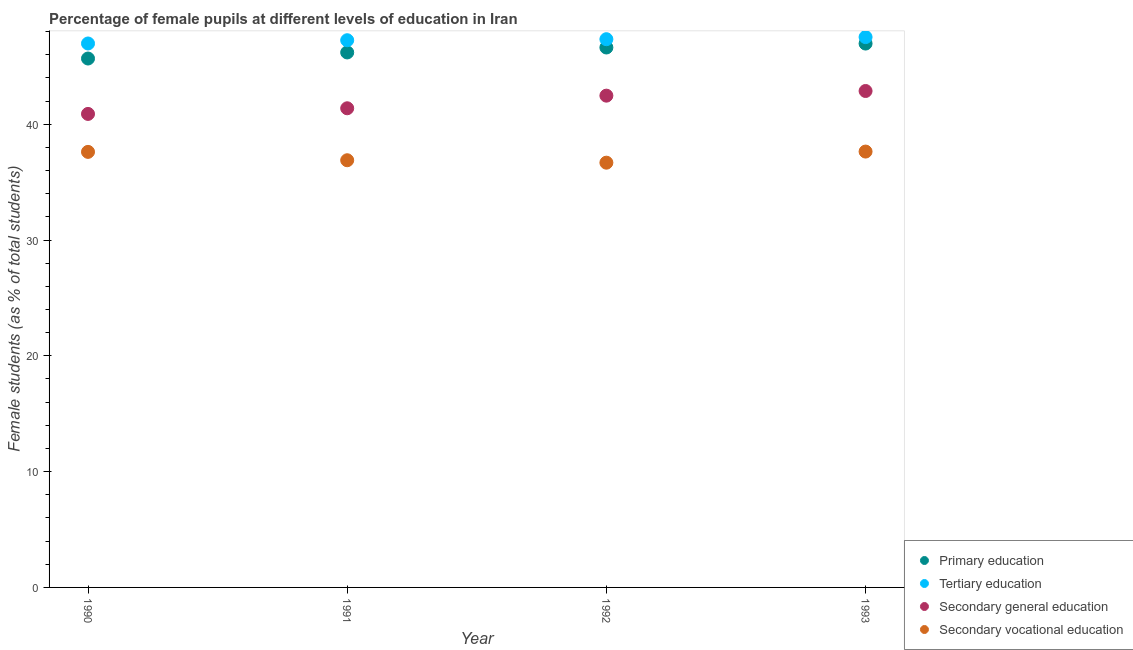How many different coloured dotlines are there?
Provide a succinct answer. 4. What is the percentage of female students in secondary education in 1993?
Offer a very short reply. 42.87. Across all years, what is the maximum percentage of female students in secondary education?
Offer a very short reply. 42.87. Across all years, what is the minimum percentage of female students in tertiary education?
Ensure brevity in your answer.  46.97. In which year was the percentage of female students in secondary education minimum?
Ensure brevity in your answer.  1990. What is the total percentage of female students in tertiary education in the graph?
Your response must be concise. 189.08. What is the difference between the percentage of female students in secondary vocational education in 1992 and that in 1993?
Your response must be concise. -0.96. What is the difference between the percentage of female students in tertiary education in 1990 and the percentage of female students in primary education in 1991?
Provide a short and direct response. 0.77. What is the average percentage of female students in secondary education per year?
Provide a short and direct response. 41.9. In the year 1990, what is the difference between the percentage of female students in tertiary education and percentage of female students in primary education?
Make the answer very short. 1.3. In how many years, is the percentage of female students in primary education greater than 38 %?
Ensure brevity in your answer.  4. What is the ratio of the percentage of female students in secondary education in 1990 to that in 1991?
Offer a terse response. 0.99. Is the difference between the percentage of female students in tertiary education in 1991 and 1992 greater than the difference between the percentage of female students in primary education in 1991 and 1992?
Your response must be concise. Yes. What is the difference between the highest and the second highest percentage of female students in secondary vocational education?
Your response must be concise. 0.03. What is the difference between the highest and the lowest percentage of female students in primary education?
Provide a succinct answer. 1.29. Is it the case that in every year, the sum of the percentage of female students in secondary vocational education and percentage of female students in primary education is greater than the sum of percentage of female students in tertiary education and percentage of female students in secondary education?
Keep it short and to the point. No. Is it the case that in every year, the sum of the percentage of female students in primary education and percentage of female students in tertiary education is greater than the percentage of female students in secondary education?
Your answer should be compact. Yes. Is the percentage of female students in tertiary education strictly greater than the percentage of female students in primary education over the years?
Your answer should be compact. Yes. How many years are there in the graph?
Offer a very short reply. 4. What is the difference between two consecutive major ticks on the Y-axis?
Offer a terse response. 10. What is the title of the graph?
Give a very brief answer. Percentage of female pupils at different levels of education in Iran. Does "UNTA" appear as one of the legend labels in the graph?
Your response must be concise. No. What is the label or title of the Y-axis?
Provide a short and direct response. Female students (as % of total students). What is the Female students (as % of total students) in Primary education in 1990?
Your answer should be very brief. 45.67. What is the Female students (as % of total students) of Tertiary education in 1990?
Ensure brevity in your answer.  46.97. What is the Female students (as % of total students) in Secondary general education in 1990?
Offer a very short reply. 40.89. What is the Female students (as % of total students) in Secondary vocational education in 1990?
Offer a very short reply. 37.61. What is the Female students (as % of total students) of Primary education in 1991?
Provide a short and direct response. 46.2. What is the Female students (as % of total students) of Tertiary education in 1991?
Your answer should be compact. 47.25. What is the Female students (as % of total students) of Secondary general education in 1991?
Your answer should be very brief. 41.37. What is the Female students (as % of total students) of Secondary vocational education in 1991?
Your response must be concise. 36.89. What is the Female students (as % of total students) in Primary education in 1992?
Offer a terse response. 46.62. What is the Female students (as % of total students) in Tertiary education in 1992?
Your response must be concise. 47.34. What is the Female students (as % of total students) in Secondary general education in 1992?
Ensure brevity in your answer.  42.46. What is the Female students (as % of total students) of Secondary vocational education in 1992?
Offer a terse response. 36.68. What is the Female students (as % of total students) of Primary education in 1993?
Provide a succinct answer. 46.96. What is the Female students (as % of total students) in Tertiary education in 1993?
Your answer should be compact. 47.52. What is the Female students (as % of total students) of Secondary general education in 1993?
Keep it short and to the point. 42.87. What is the Female students (as % of total students) in Secondary vocational education in 1993?
Offer a very short reply. 37.64. Across all years, what is the maximum Female students (as % of total students) in Primary education?
Give a very brief answer. 46.96. Across all years, what is the maximum Female students (as % of total students) in Tertiary education?
Ensure brevity in your answer.  47.52. Across all years, what is the maximum Female students (as % of total students) of Secondary general education?
Your response must be concise. 42.87. Across all years, what is the maximum Female students (as % of total students) of Secondary vocational education?
Ensure brevity in your answer.  37.64. Across all years, what is the minimum Female students (as % of total students) in Primary education?
Your answer should be compact. 45.67. Across all years, what is the minimum Female students (as % of total students) in Tertiary education?
Offer a very short reply. 46.97. Across all years, what is the minimum Female students (as % of total students) of Secondary general education?
Your response must be concise. 40.89. Across all years, what is the minimum Female students (as % of total students) of Secondary vocational education?
Provide a short and direct response. 36.68. What is the total Female students (as % of total students) in Primary education in the graph?
Your response must be concise. 185.45. What is the total Female students (as % of total students) of Tertiary education in the graph?
Your response must be concise. 189.08. What is the total Female students (as % of total students) in Secondary general education in the graph?
Your response must be concise. 167.59. What is the total Female students (as % of total students) in Secondary vocational education in the graph?
Ensure brevity in your answer.  148.81. What is the difference between the Female students (as % of total students) in Primary education in 1990 and that in 1991?
Your answer should be very brief. -0.52. What is the difference between the Female students (as % of total students) of Tertiary education in 1990 and that in 1991?
Provide a succinct answer. -0.28. What is the difference between the Female students (as % of total students) of Secondary general education in 1990 and that in 1991?
Your answer should be compact. -0.49. What is the difference between the Female students (as % of total students) in Secondary vocational education in 1990 and that in 1991?
Provide a succinct answer. 0.72. What is the difference between the Female students (as % of total students) of Primary education in 1990 and that in 1992?
Your answer should be compact. -0.95. What is the difference between the Female students (as % of total students) in Tertiary education in 1990 and that in 1992?
Offer a terse response. -0.37. What is the difference between the Female students (as % of total students) in Secondary general education in 1990 and that in 1992?
Offer a very short reply. -1.58. What is the difference between the Female students (as % of total students) of Secondary vocational education in 1990 and that in 1992?
Your response must be concise. 0.93. What is the difference between the Female students (as % of total students) in Primary education in 1990 and that in 1993?
Your response must be concise. -1.29. What is the difference between the Female students (as % of total students) in Tertiary education in 1990 and that in 1993?
Offer a very short reply. -0.55. What is the difference between the Female students (as % of total students) in Secondary general education in 1990 and that in 1993?
Your response must be concise. -1.98. What is the difference between the Female students (as % of total students) of Secondary vocational education in 1990 and that in 1993?
Ensure brevity in your answer.  -0.03. What is the difference between the Female students (as % of total students) of Primary education in 1991 and that in 1992?
Make the answer very short. -0.43. What is the difference between the Female students (as % of total students) in Tertiary education in 1991 and that in 1992?
Offer a terse response. -0.09. What is the difference between the Female students (as % of total students) in Secondary general education in 1991 and that in 1992?
Make the answer very short. -1.09. What is the difference between the Female students (as % of total students) of Secondary vocational education in 1991 and that in 1992?
Your answer should be compact. 0.21. What is the difference between the Female students (as % of total students) in Primary education in 1991 and that in 1993?
Offer a terse response. -0.77. What is the difference between the Female students (as % of total students) of Tertiary education in 1991 and that in 1993?
Ensure brevity in your answer.  -0.27. What is the difference between the Female students (as % of total students) in Secondary general education in 1991 and that in 1993?
Your answer should be compact. -1.49. What is the difference between the Female students (as % of total students) in Secondary vocational education in 1991 and that in 1993?
Provide a short and direct response. -0.75. What is the difference between the Female students (as % of total students) in Primary education in 1992 and that in 1993?
Ensure brevity in your answer.  -0.34. What is the difference between the Female students (as % of total students) of Tertiary education in 1992 and that in 1993?
Ensure brevity in your answer.  -0.18. What is the difference between the Female students (as % of total students) of Secondary general education in 1992 and that in 1993?
Offer a very short reply. -0.4. What is the difference between the Female students (as % of total students) in Secondary vocational education in 1992 and that in 1993?
Provide a short and direct response. -0.96. What is the difference between the Female students (as % of total students) of Primary education in 1990 and the Female students (as % of total students) of Tertiary education in 1991?
Your answer should be compact. -1.58. What is the difference between the Female students (as % of total students) of Primary education in 1990 and the Female students (as % of total students) of Secondary general education in 1991?
Ensure brevity in your answer.  4.3. What is the difference between the Female students (as % of total students) of Primary education in 1990 and the Female students (as % of total students) of Secondary vocational education in 1991?
Keep it short and to the point. 8.78. What is the difference between the Female students (as % of total students) of Tertiary education in 1990 and the Female students (as % of total students) of Secondary general education in 1991?
Your answer should be very brief. 5.59. What is the difference between the Female students (as % of total students) in Tertiary education in 1990 and the Female students (as % of total students) in Secondary vocational education in 1991?
Offer a terse response. 10.08. What is the difference between the Female students (as % of total students) in Secondary general education in 1990 and the Female students (as % of total students) in Secondary vocational education in 1991?
Provide a short and direct response. 4. What is the difference between the Female students (as % of total students) of Primary education in 1990 and the Female students (as % of total students) of Tertiary education in 1992?
Provide a short and direct response. -1.67. What is the difference between the Female students (as % of total students) in Primary education in 1990 and the Female students (as % of total students) in Secondary general education in 1992?
Your answer should be very brief. 3.21. What is the difference between the Female students (as % of total students) of Primary education in 1990 and the Female students (as % of total students) of Secondary vocational education in 1992?
Ensure brevity in your answer.  8.99. What is the difference between the Female students (as % of total students) of Tertiary education in 1990 and the Female students (as % of total students) of Secondary general education in 1992?
Make the answer very short. 4.5. What is the difference between the Female students (as % of total students) of Tertiary education in 1990 and the Female students (as % of total students) of Secondary vocational education in 1992?
Ensure brevity in your answer.  10.29. What is the difference between the Female students (as % of total students) of Secondary general education in 1990 and the Female students (as % of total students) of Secondary vocational education in 1992?
Provide a short and direct response. 4.21. What is the difference between the Female students (as % of total students) of Primary education in 1990 and the Female students (as % of total students) of Tertiary education in 1993?
Keep it short and to the point. -1.85. What is the difference between the Female students (as % of total students) in Primary education in 1990 and the Female students (as % of total students) in Secondary general education in 1993?
Provide a short and direct response. 2.8. What is the difference between the Female students (as % of total students) in Primary education in 1990 and the Female students (as % of total students) in Secondary vocational education in 1993?
Your response must be concise. 8.03. What is the difference between the Female students (as % of total students) in Tertiary education in 1990 and the Female students (as % of total students) in Secondary general education in 1993?
Keep it short and to the point. 4.1. What is the difference between the Female students (as % of total students) in Tertiary education in 1990 and the Female students (as % of total students) in Secondary vocational education in 1993?
Provide a short and direct response. 9.33. What is the difference between the Female students (as % of total students) in Secondary general education in 1990 and the Female students (as % of total students) in Secondary vocational education in 1993?
Provide a short and direct response. 3.25. What is the difference between the Female students (as % of total students) of Primary education in 1991 and the Female students (as % of total students) of Tertiary education in 1992?
Your answer should be compact. -1.14. What is the difference between the Female students (as % of total students) in Primary education in 1991 and the Female students (as % of total students) in Secondary general education in 1992?
Your answer should be compact. 3.73. What is the difference between the Female students (as % of total students) of Primary education in 1991 and the Female students (as % of total students) of Secondary vocational education in 1992?
Make the answer very short. 9.52. What is the difference between the Female students (as % of total students) of Tertiary education in 1991 and the Female students (as % of total students) of Secondary general education in 1992?
Provide a short and direct response. 4.79. What is the difference between the Female students (as % of total students) in Tertiary education in 1991 and the Female students (as % of total students) in Secondary vocational education in 1992?
Keep it short and to the point. 10.57. What is the difference between the Female students (as % of total students) of Secondary general education in 1991 and the Female students (as % of total students) of Secondary vocational education in 1992?
Keep it short and to the point. 4.7. What is the difference between the Female students (as % of total students) of Primary education in 1991 and the Female students (as % of total students) of Tertiary education in 1993?
Offer a very short reply. -1.33. What is the difference between the Female students (as % of total students) of Primary education in 1991 and the Female students (as % of total students) of Secondary general education in 1993?
Keep it short and to the point. 3.33. What is the difference between the Female students (as % of total students) in Primary education in 1991 and the Female students (as % of total students) in Secondary vocational education in 1993?
Make the answer very short. 8.56. What is the difference between the Female students (as % of total students) of Tertiary education in 1991 and the Female students (as % of total students) of Secondary general education in 1993?
Provide a succinct answer. 4.38. What is the difference between the Female students (as % of total students) of Tertiary education in 1991 and the Female students (as % of total students) of Secondary vocational education in 1993?
Your answer should be very brief. 9.61. What is the difference between the Female students (as % of total students) of Secondary general education in 1991 and the Female students (as % of total students) of Secondary vocational education in 1993?
Provide a succinct answer. 3.74. What is the difference between the Female students (as % of total students) in Primary education in 1992 and the Female students (as % of total students) in Tertiary education in 1993?
Offer a very short reply. -0.9. What is the difference between the Female students (as % of total students) in Primary education in 1992 and the Female students (as % of total students) in Secondary general education in 1993?
Your response must be concise. 3.76. What is the difference between the Female students (as % of total students) in Primary education in 1992 and the Female students (as % of total students) in Secondary vocational education in 1993?
Your answer should be compact. 8.99. What is the difference between the Female students (as % of total students) of Tertiary education in 1992 and the Female students (as % of total students) of Secondary general education in 1993?
Offer a terse response. 4.47. What is the difference between the Female students (as % of total students) of Tertiary education in 1992 and the Female students (as % of total students) of Secondary vocational education in 1993?
Your answer should be compact. 9.7. What is the difference between the Female students (as % of total students) in Secondary general education in 1992 and the Female students (as % of total students) in Secondary vocational education in 1993?
Provide a short and direct response. 4.83. What is the average Female students (as % of total students) in Primary education per year?
Your answer should be compact. 46.36. What is the average Female students (as % of total students) in Tertiary education per year?
Offer a very short reply. 47.27. What is the average Female students (as % of total students) in Secondary general education per year?
Your answer should be very brief. 41.9. What is the average Female students (as % of total students) of Secondary vocational education per year?
Your answer should be compact. 37.2. In the year 1990, what is the difference between the Female students (as % of total students) of Primary education and Female students (as % of total students) of Tertiary education?
Offer a terse response. -1.3. In the year 1990, what is the difference between the Female students (as % of total students) of Primary education and Female students (as % of total students) of Secondary general education?
Your answer should be compact. 4.78. In the year 1990, what is the difference between the Female students (as % of total students) of Primary education and Female students (as % of total students) of Secondary vocational education?
Offer a terse response. 8.06. In the year 1990, what is the difference between the Female students (as % of total students) in Tertiary education and Female students (as % of total students) in Secondary general education?
Offer a very short reply. 6.08. In the year 1990, what is the difference between the Female students (as % of total students) of Tertiary education and Female students (as % of total students) of Secondary vocational education?
Give a very brief answer. 9.36. In the year 1990, what is the difference between the Female students (as % of total students) in Secondary general education and Female students (as % of total students) in Secondary vocational education?
Make the answer very short. 3.28. In the year 1991, what is the difference between the Female students (as % of total students) in Primary education and Female students (as % of total students) in Tertiary education?
Give a very brief answer. -1.06. In the year 1991, what is the difference between the Female students (as % of total students) in Primary education and Female students (as % of total students) in Secondary general education?
Ensure brevity in your answer.  4.82. In the year 1991, what is the difference between the Female students (as % of total students) in Primary education and Female students (as % of total students) in Secondary vocational education?
Give a very brief answer. 9.31. In the year 1991, what is the difference between the Female students (as % of total students) in Tertiary education and Female students (as % of total students) in Secondary general education?
Ensure brevity in your answer.  5.88. In the year 1991, what is the difference between the Female students (as % of total students) in Tertiary education and Female students (as % of total students) in Secondary vocational education?
Keep it short and to the point. 10.36. In the year 1991, what is the difference between the Female students (as % of total students) in Secondary general education and Female students (as % of total students) in Secondary vocational education?
Offer a very short reply. 4.49. In the year 1992, what is the difference between the Female students (as % of total students) in Primary education and Female students (as % of total students) in Tertiary education?
Make the answer very short. -0.72. In the year 1992, what is the difference between the Female students (as % of total students) of Primary education and Female students (as % of total students) of Secondary general education?
Provide a succinct answer. 4.16. In the year 1992, what is the difference between the Female students (as % of total students) in Primary education and Female students (as % of total students) in Secondary vocational education?
Keep it short and to the point. 9.95. In the year 1992, what is the difference between the Female students (as % of total students) of Tertiary education and Female students (as % of total students) of Secondary general education?
Ensure brevity in your answer.  4.87. In the year 1992, what is the difference between the Female students (as % of total students) of Tertiary education and Female students (as % of total students) of Secondary vocational education?
Your answer should be compact. 10.66. In the year 1992, what is the difference between the Female students (as % of total students) in Secondary general education and Female students (as % of total students) in Secondary vocational education?
Make the answer very short. 5.79. In the year 1993, what is the difference between the Female students (as % of total students) of Primary education and Female students (as % of total students) of Tertiary education?
Keep it short and to the point. -0.56. In the year 1993, what is the difference between the Female students (as % of total students) in Primary education and Female students (as % of total students) in Secondary general education?
Provide a succinct answer. 4.1. In the year 1993, what is the difference between the Female students (as % of total students) in Primary education and Female students (as % of total students) in Secondary vocational education?
Your answer should be compact. 9.33. In the year 1993, what is the difference between the Female students (as % of total students) of Tertiary education and Female students (as % of total students) of Secondary general education?
Offer a terse response. 4.65. In the year 1993, what is the difference between the Female students (as % of total students) of Tertiary education and Female students (as % of total students) of Secondary vocational education?
Your answer should be compact. 9.88. In the year 1993, what is the difference between the Female students (as % of total students) in Secondary general education and Female students (as % of total students) in Secondary vocational education?
Your answer should be compact. 5.23. What is the ratio of the Female students (as % of total students) in Primary education in 1990 to that in 1991?
Give a very brief answer. 0.99. What is the ratio of the Female students (as % of total students) of Secondary vocational education in 1990 to that in 1991?
Your answer should be compact. 1.02. What is the ratio of the Female students (as % of total students) of Primary education in 1990 to that in 1992?
Offer a very short reply. 0.98. What is the ratio of the Female students (as % of total students) in Secondary general education in 1990 to that in 1992?
Offer a terse response. 0.96. What is the ratio of the Female students (as % of total students) of Secondary vocational education in 1990 to that in 1992?
Your answer should be very brief. 1.03. What is the ratio of the Female students (as % of total students) of Primary education in 1990 to that in 1993?
Offer a very short reply. 0.97. What is the ratio of the Female students (as % of total students) in Tertiary education in 1990 to that in 1993?
Make the answer very short. 0.99. What is the ratio of the Female students (as % of total students) in Secondary general education in 1990 to that in 1993?
Your answer should be very brief. 0.95. What is the ratio of the Female students (as % of total students) in Secondary vocational education in 1990 to that in 1993?
Your answer should be compact. 1. What is the ratio of the Female students (as % of total students) in Primary education in 1991 to that in 1992?
Offer a terse response. 0.99. What is the ratio of the Female students (as % of total students) in Tertiary education in 1991 to that in 1992?
Provide a short and direct response. 1. What is the ratio of the Female students (as % of total students) in Secondary general education in 1991 to that in 1992?
Your answer should be very brief. 0.97. What is the ratio of the Female students (as % of total students) of Primary education in 1991 to that in 1993?
Your answer should be very brief. 0.98. What is the ratio of the Female students (as % of total students) in Secondary general education in 1991 to that in 1993?
Provide a short and direct response. 0.97. What is the ratio of the Female students (as % of total students) in Secondary vocational education in 1991 to that in 1993?
Offer a terse response. 0.98. What is the ratio of the Female students (as % of total students) of Primary education in 1992 to that in 1993?
Offer a terse response. 0.99. What is the ratio of the Female students (as % of total students) in Secondary general education in 1992 to that in 1993?
Provide a succinct answer. 0.99. What is the ratio of the Female students (as % of total students) of Secondary vocational education in 1992 to that in 1993?
Your answer should be very brief. 0.97. What is the difference between the highest and the second highest Female students (as % of total students) in Primary education?
Give a very brief answer. 0.34. What is the difference between the highest and the second highest Female students (as % of total students) of Tertiary education?
Ensure brevity in your answer.  0.18. What is the difference between the highest and the second highest Female students (as % of total students) in Secondary general education?
Keep it short and to the point. 0.4. What is the difference between the highest and the second highest Female students (as % of total students) of Secondary vocational education?
Give a very brief answer. 0.03. What is the difference between the highest and the lowest Female students (as % of total students) of Primary education?
Ensure brevity in your answer.  1.29. What is the difference between the highest and the lowest Female students (as % of total students) of Tertiary education?
Make the answer very short. 0.55. What is the difference between the highest and the lowest Female students (as % of total students) in Secondary general education?
Keep it short and to the point. 1.98. What is the difference between the highest and the lowest Female students (as % of total students) in Secondary vocational education?
Make the answer very short. 0.96. 